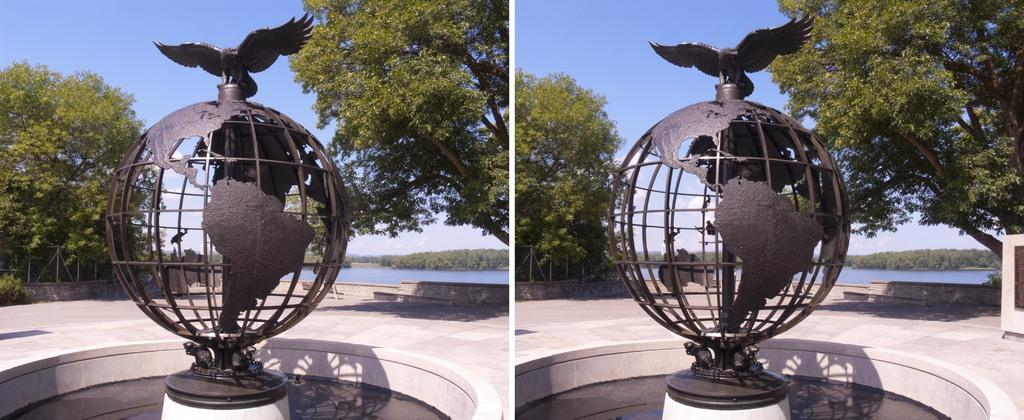What is the main subject of the statue in the picture? The main subject of the statue is a globe. Are there any additional elements on the statue? Yes, there is an eagle on the statue. What natural feature can be seen in the picture? There is a lake in the picture. What type of vegetation is present in the picture? There are trees and plants in the picture. What is the condition of the sky in the picture? The sky is clear in the picture. What type of story is being told by the silk in the image? There is no silk present in the image, so no story can be told by it. 